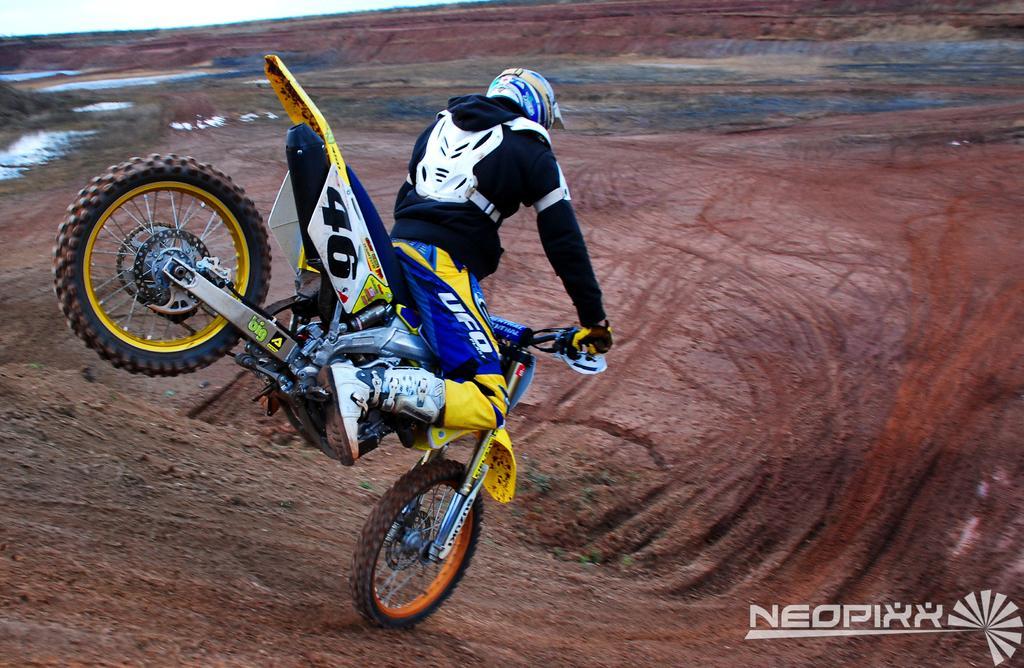Describe this image in one or two sentences. Here in this picture we can see a person riding a motor bike over a place and we can see he is wearing jacket, gloves and helmet on him and we can see water present on the ground at some places over there. 